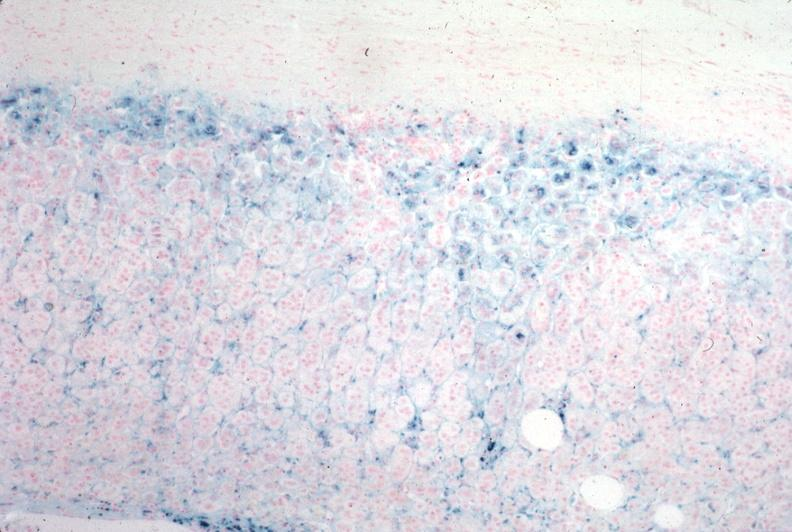s endocrine present?
Answer the question using a single word or phrase. Yes 